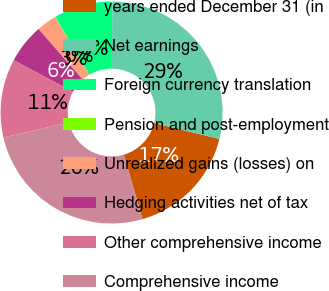Convert chart to OTSL. <chart><loc_0><loc_0><loc_500><loc_500><pie_chart><fcel>years ended December 31 (in<fcel>Net earnings<fcel>Foreign currency translation<fcel>Pension and post-employment<fcel>Unrealized gains (losses) on<fcel>Hedging activities net of tax<fcel>Other comprehensive income<fcel>Comprehensive income<nl><fcel>16.68%<fcel>28.72%<fcel>8.58%<fcel>0.06%<fcel>2.9%<fcel>5.74%<fcel>11.43%<fcel>25.88%<nl></chart> 